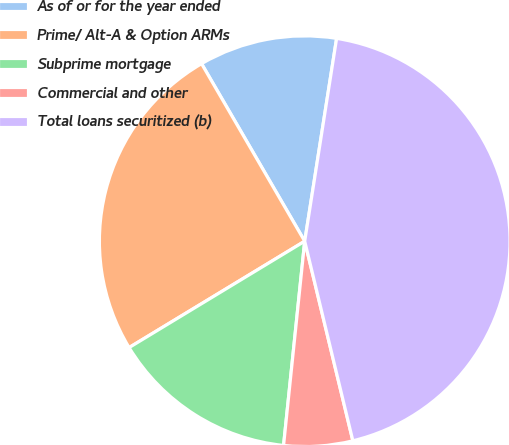<chart> <loc_0><loc_0><loc_500><loc_500><pie_chart><fcel>As of or for the year ended<fcel>Prime/ Alt-A & Option ARMs<fcel>Subprime mortgage<fcel>Commercial and other<fcel>Total loans securitized (b)<nl><fcel>10.86%<fcel>25.29%<fcel>14.69%<fcel>5.41%<fcel>43.75%<nl></chart> 